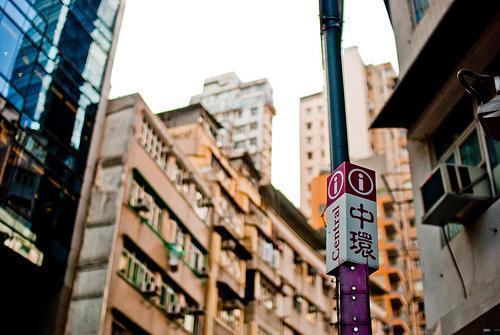How many signs are in the picture?
Give a very brief answer. 1. 